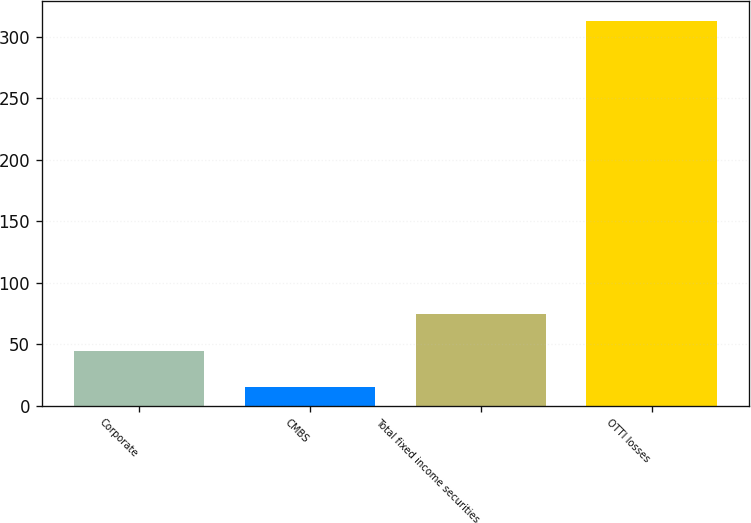Convert chart. <chart><loc_0><loc_0><loc_500><loc_500><bar_chart><fcel>Corporate<fcel>CMBS<fcel>Total fixed income securities<fcel>OTTI losses<nl><fcel>44.8<fcel>15<fcel>74.6<fcel>313<nl></chart> 